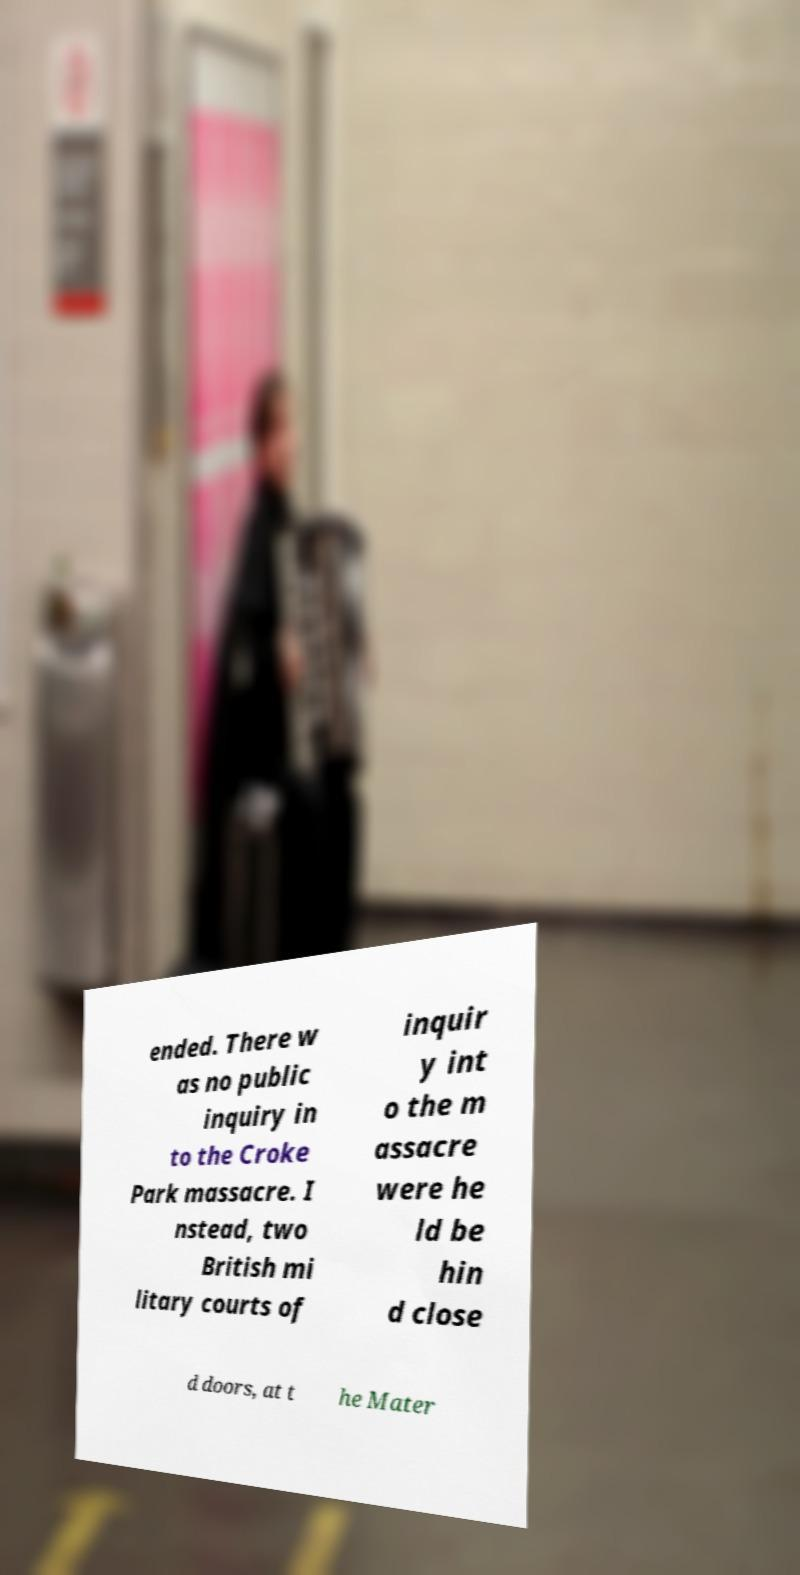Please read and relay the text visible in this image. What does it say? ended. There w as no public inquiry in to the Croke Park massacre. I nstead, two British mi litary courts of inquir y int o the m assacre were he ld be hin d close d doors, at t he Mater 